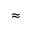<formula> <loc_0><loc_0><loc_500><loc_500>\approx</formula> 